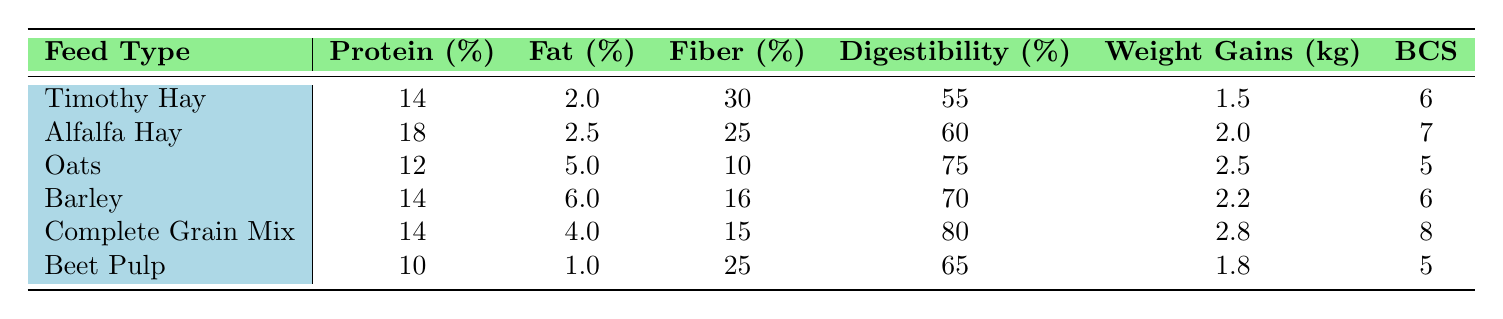What is the protein content of Alfalfa Hay? The table indicates that the protein content for Alfalfa Hay is listed directly under the Protein (%) column, which shows a value of 18.
Answer: 18 Which feed type has the highest weight gains? By looking for the maximum value in the Weight Gains (kg) column, we see that Complete Grain Mix has the highest value of 2.8.
Answer: Complete Grain Mix What is the average body condition score (BCS) of all the feed types? To find the average BCS, we sum all the BCS values (6 + 7 + 5 + 6 + 8 + 5) = 37 and divide by the number of feed types (6). Thus, average BCS = 37 / 6 = 6.17.
Answer: 6.17 Did any feed type have a fat content greater than 5%? Checking the Fat (%) column, we see that Oats (5.0) and Barley (6.0) both have fat content greater than 5%. Therefore, the answer is yes.
Answer: Yes Which feed type has both high digestibility and high protein content? We need to assess the values in the Digestibility (%) and Protein (%) columns. The feed types with digestibility over 60% are Alfalfa Hay (60), Oats (75), Barley (70), and Complete Grain Mix (80), and all have protein content of 14% or higher, thus both Alfalfa Hay and Complete Grain Mix meet this criteria.
Answer: Alfalfa Hay, Complete Grain Mix 